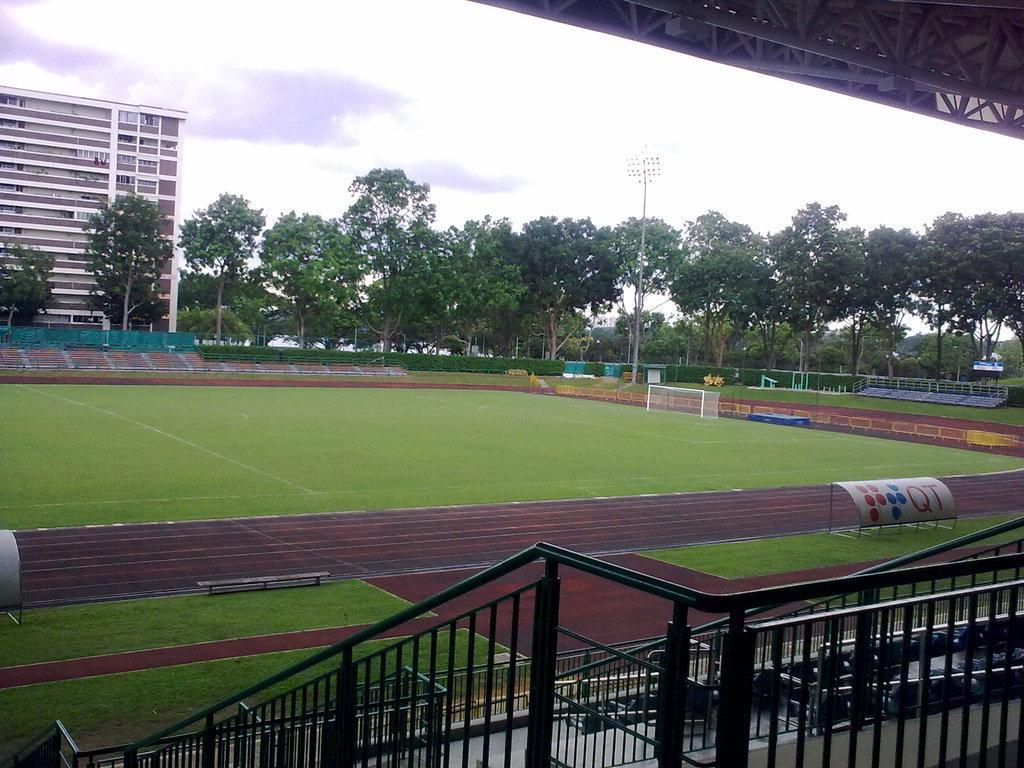Could you give a brief overview of what you see in this image? At the bottom of the image we can see the fences. In the background, we can see the sky, clouds, trees, one building, grass, one pole, goal post and a few other objects. 